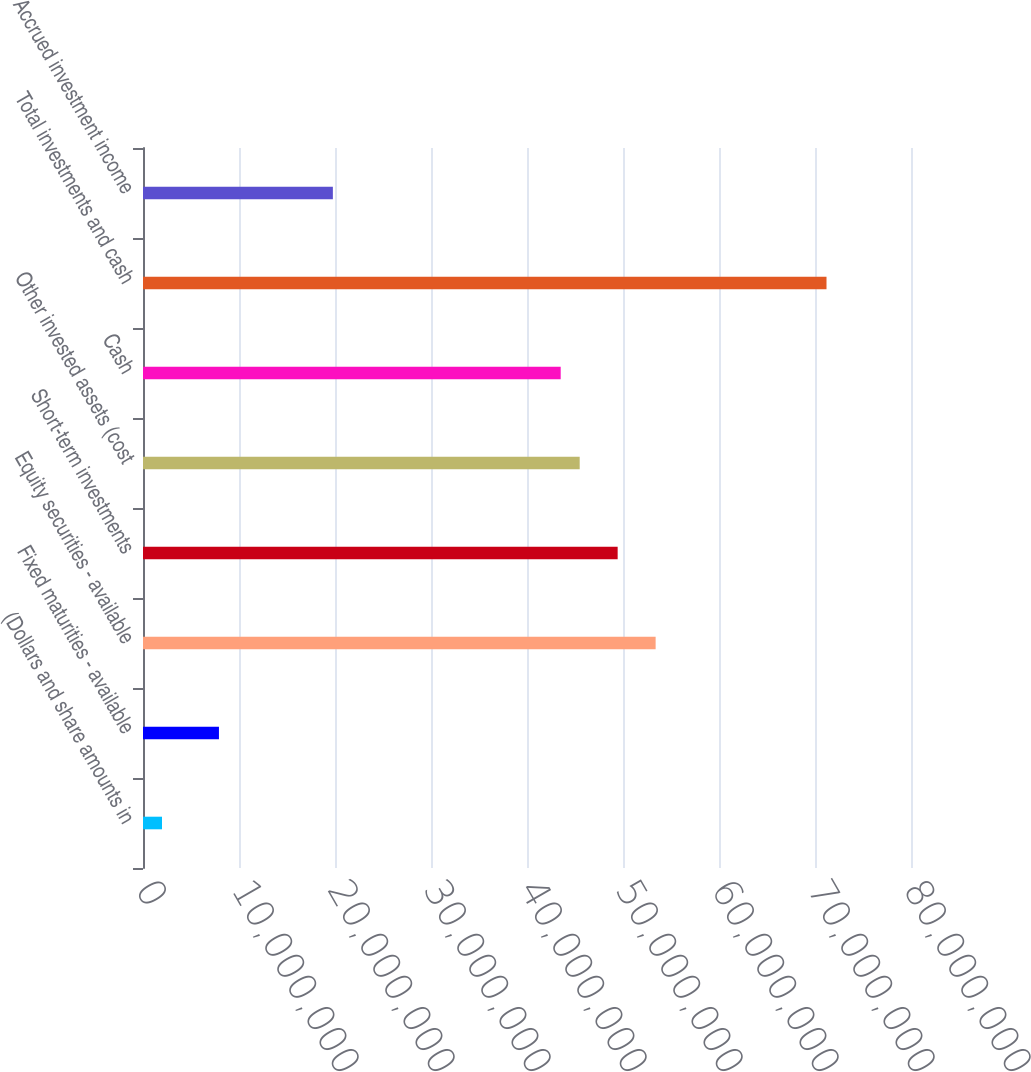Convert chart to OTSL. <chart><loc_0><loc_0><loc_500><loc_500><bar_chart><fcel>(Dollars and share amounts in<fcel>Fixed maturities - available<fcel>Equity securities - available<fcel>Short-term investments<fcel>Other invested assets (cost<fcel>Cash<fcel>Total investments and cash<fcel>Accrued investment income<nl><fcel>1.97839e+06<fcel>7.91157e+06<fcel>5.33992e+07<fcel>4.94438e+07<fcel>4.54883e+07<fcel>4.35106e+07<fcel>7.11987e+07<fcel>1.97779e+07<nl></chart> 